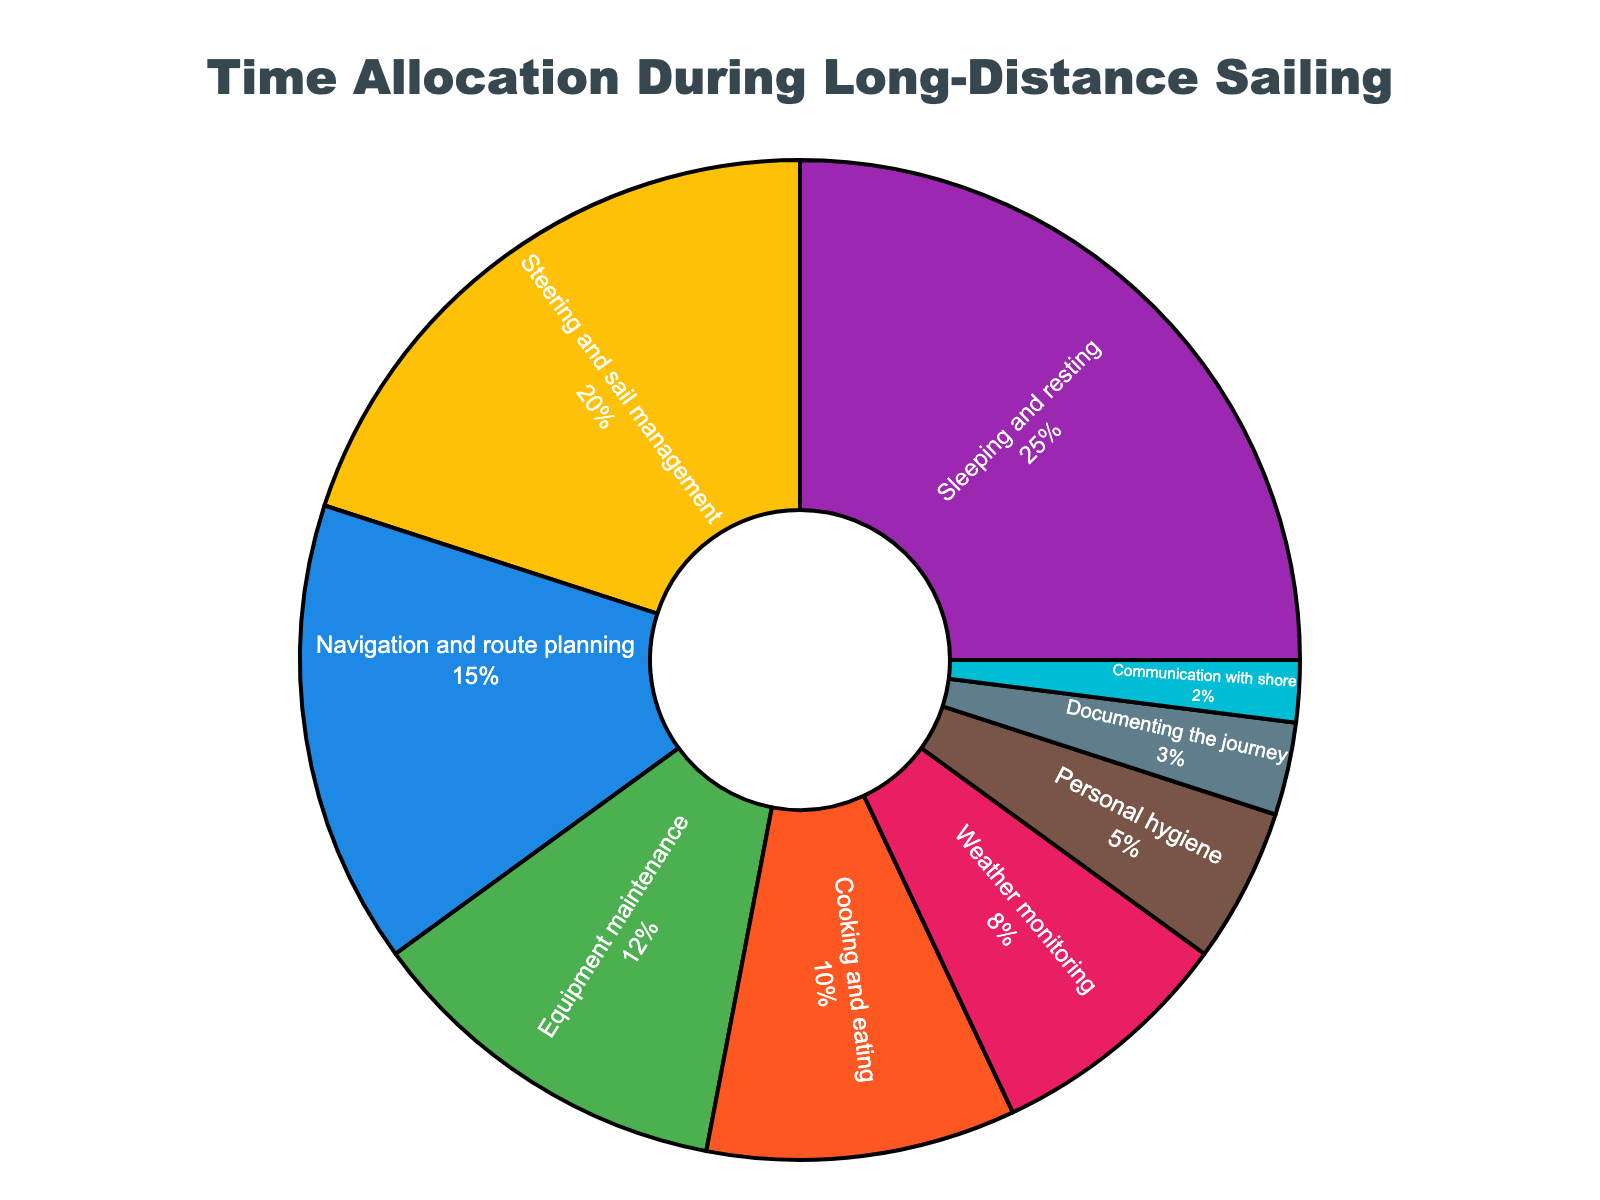Which activity takes up the most time? The activity with the highest percentage in the pie chart is the one that takes up the most time. Here, Sleeping and resting is the largest segment at 25%.
Answer: Sleeping and resting What percentage of time is spent on both Steering and sail management and Navigation and route planning combined? Add the percentages for Steering and sail management (20%) and Navigation and route planning (15%) together.
Answer: 35% Which activity takes up less time: Weather monitoring or Documenting the journey? Compare the percentages for Weather monitoring (8%) and Documenting the journey (3%). Documenting the journey is the smaller percentage.
Answer: Documenting the journey Is more time spent on Cooking and eating or Equipment maintenance? Compare the percentages for Cooking and eating (10%) and Equipment maintenance (12%). Equipment maintenance has a higher percentage.
Answer: Equipment maintenance What is the difference in time allocation between Sleeping and resting and Communication with shore? Subtract the percentage for Communication with shore (2%) from Sleeping and resting (25%). The difference is 25% - 2% = 23%.
Answer: 23% How much more time is spent on Personal hygiene compared to Documenting the journey? Subtract the percentage for Documenting the journey (3%) from Personal hygiene (5%). The difference is 5% - 3% = 2%.
Answer: 2% If you combine the time spent on Equipment maintenance, Weather monitoring, and Communication with shore, what is the total percentage? Add the percentages for Equipment maintenance (12%), Weather monitoring (8%), and Communication with shore (2%) together. The total is 12% + 8% + 2% = 22%.
Answer: 22% What percentage of time is spent on non-essential activities (Cooking and eating, Personal hygiene, Documenting the journey, Communication with shore)? Add the percentages for Cooking and eating (10%), Personal hygiene (5%), Documenting the journey (3%), and Communication with shore (2%). The total is 10% + 5% + 3% + 2% = 20%.
Answer: 20% Which is greater: the time spent on Navigation and route planning or the combined time spent on Documenting the journey and Personal hygiene? Compare Navigation and route planning (15%) with the combined percentage of Documenting the journey (3%) and Personal hygiene (5%). The combined total is 3% + 5% = 8%, which is less than 15%.
Answer: Navigation and route planning 